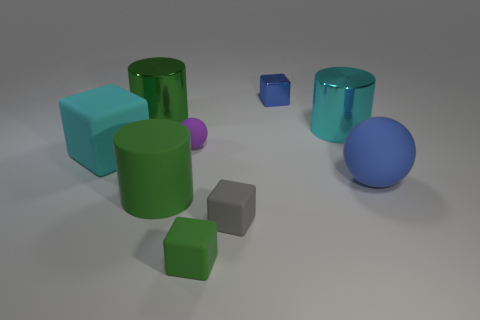Subtract all yellow blocks. Subtract all gray spheres. How many blocks are left? 4 Add 1 big cyan matte cubes. How many objects exist? 10 Subtract all cylinders. How many objects are left? 6 Add 2 tiny blue cubes. How many tiny blue cubes are left? 3 Add 2 large cyan metallic things. How many large cyan metallic things exist? 3 Subtract 0 gray balls. How many objects are left? 9 Subtract all tiny blue matte things. Subtract all big green cylinders. How many objects are left? 7 